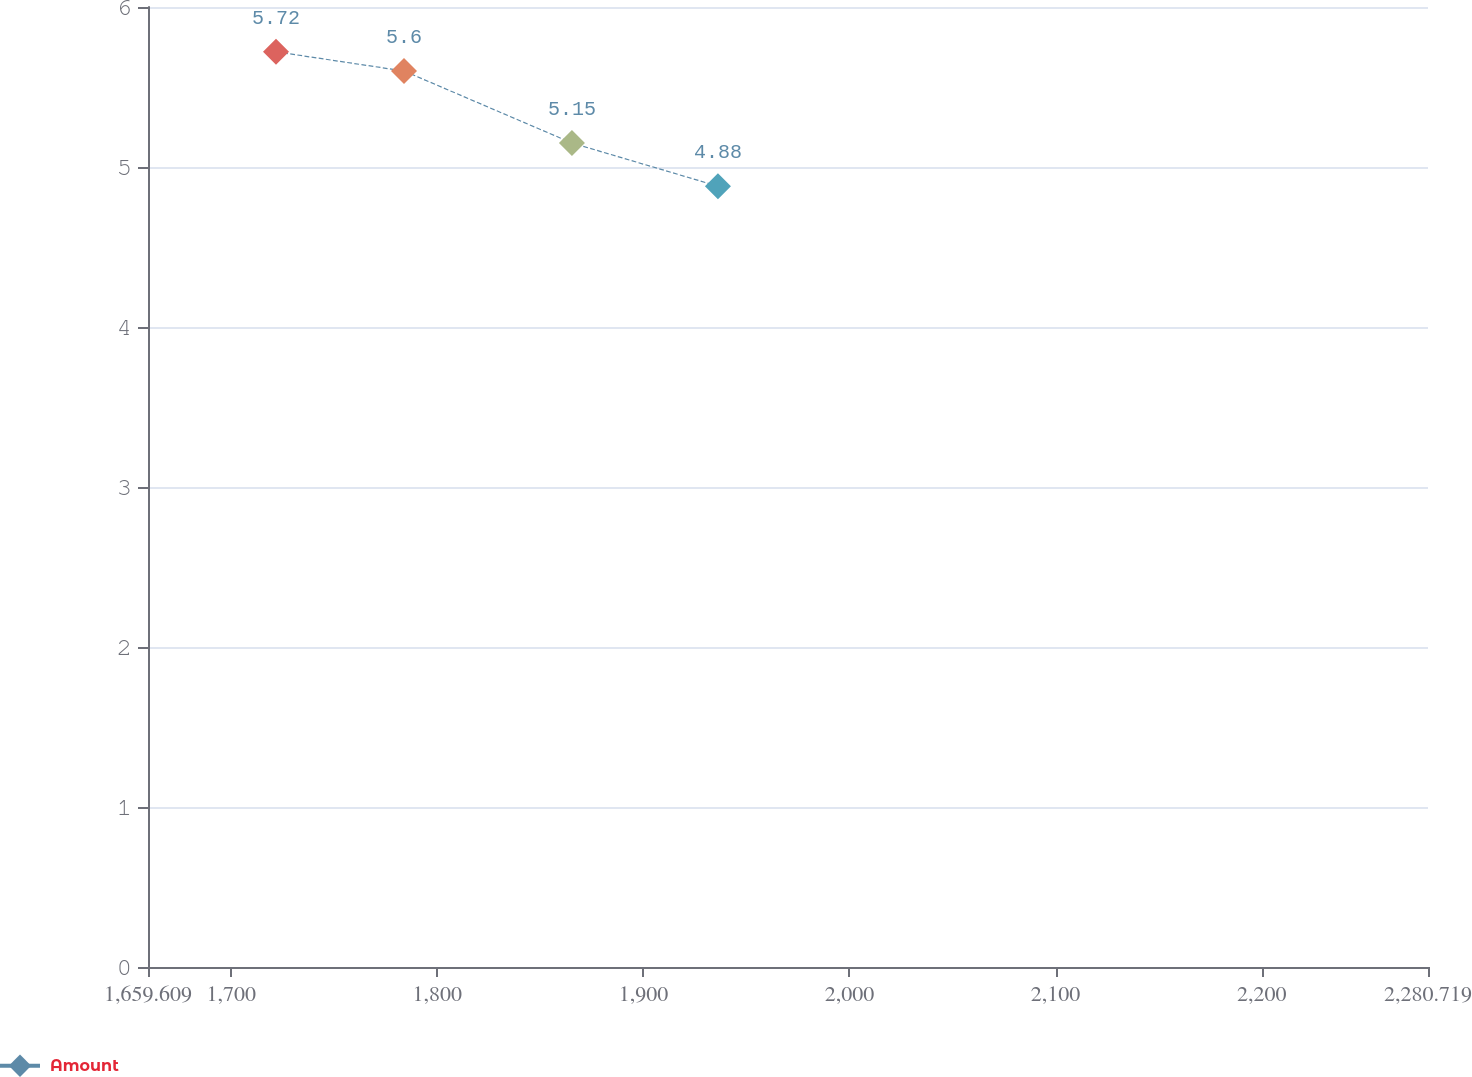Convert chart. <chart><loc_0><loc_0><loc_500><loc_500><line_chart><ecel><fcel>Amount<nl><fcel>1721.72<fcel>5.72<nl><fcel>1783.83<fcel>5.6<nl><fcel>1865.32<fcel>5.15<nl><fcel>1936.16<fcel>4.88<nl><fcel>2342.83<fcel>5.8<nl></chart> 